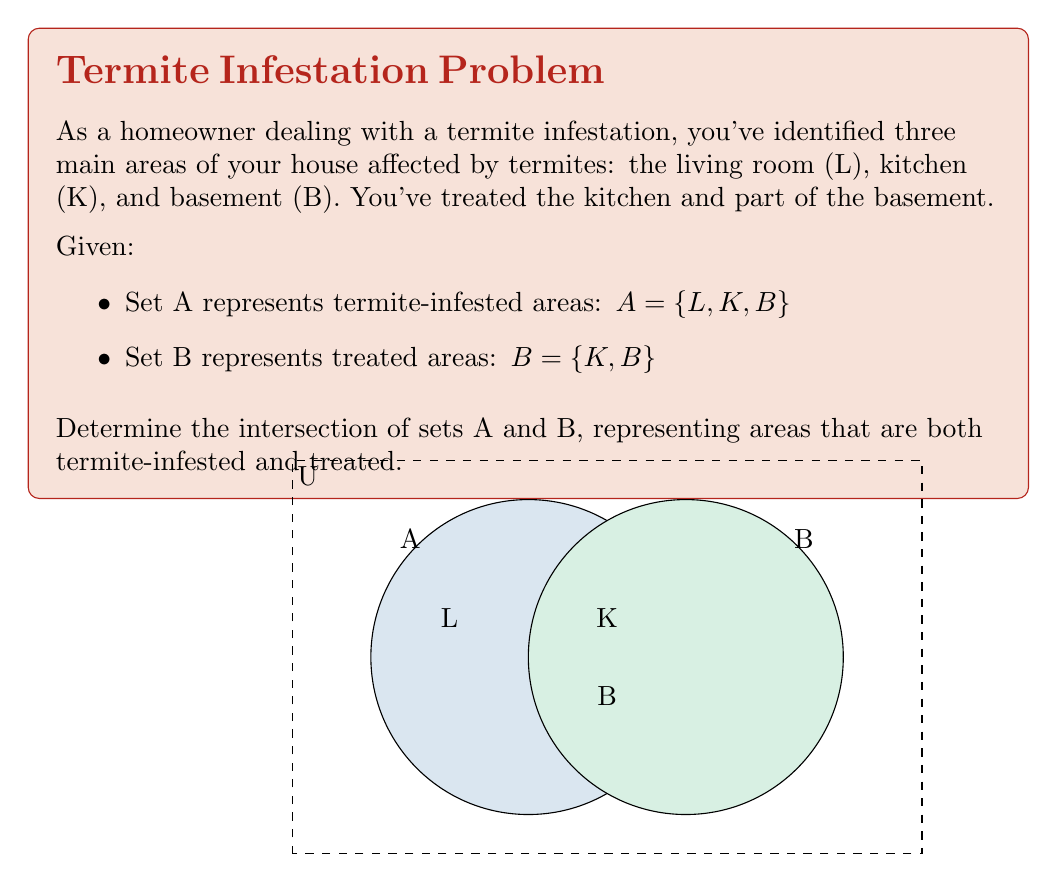Give your solution to this math problem. Let's approach this step-by-step:

1) We need to find the intersection of sets A and B, denoted as $A \cap B$.

2) The intersection of two sets contains all elements that are common to both sets.

3) Set A contains: $A = \{L, K, B\}$
   Set B contains: $B = \{K, B\}$

4) To find $A \cap B$, we identify elements present in both A and B:
   - L is only in A, not in B
   - K is in both A and B
   - B is in both A and B

5) Therefore, the elements common to both sets are K and B.

6) We can write this intersection as: $A \cap B = \{K, B\}$

This result shows that the kitchen (K) and basement (B) are both termite-infested areas that have been treated.
Answer: $A \cap B = \{K, B\}$ 